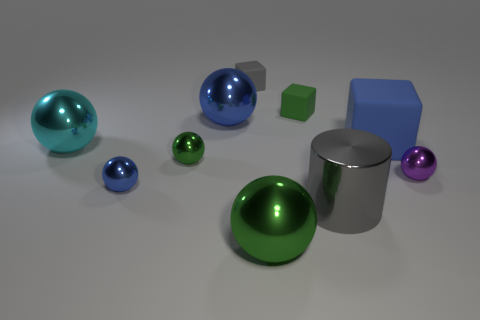How many other objects are there of the same material as the cyan ball?
Make the answer very short. 6. There is a shiny cylinder in front of the cyan metal sphere; what color is it?
Provide a short and direct response. Gray. What number of things are tiny metallic spheres behind the big green metal thing or green things behind the large cyan shiny ball?
Keep it short and to the point. 4. What number of small gray objects are the same shape as the big green metallic thing?
Offer a terse response. 0. There is a matte thing that is the same size as the metal cylinder; what color is it?
Give a very brief answer. Blue. What is the color of the tiny shiny sphere right of the green ball on the left side of the large metal ball that is in front of the big cyan metal sphere?
Provide a succinct answer. Purple. Do the cyan shiny sphere and the metallic cylinder right of the large cyan thing have the same size?
Your response must be concise. Yes. How many objects are either tiny green matte objects or large blue matte objects?
Your response must be concise. 2. Is there a large green cylinder made of the same material as the cyan object?
Your answer should be compact. No. There is a cube that is the same color as the cylinder; what size is it?
Your response must be concise. Small. 